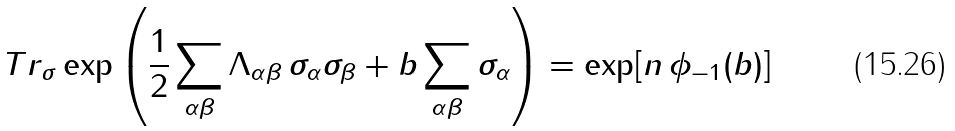Convert formula to latex. <formula><loc_0><loc_0><loc_500><loc_500>T r _ { \sigma } \exp \left ( \frac { 1 } { 2 } \sum _ { \alpha \beta } \Lambda _ { \alpha \beta } \, \sigma _ { \alpha } \sigma _ { \beta } + b \sum _ { \alpha \beta } \sigma _ { \alpha } \right ) = \exp [ { n \, \phi _ { - 1 } ( b ) } ]</formula> 